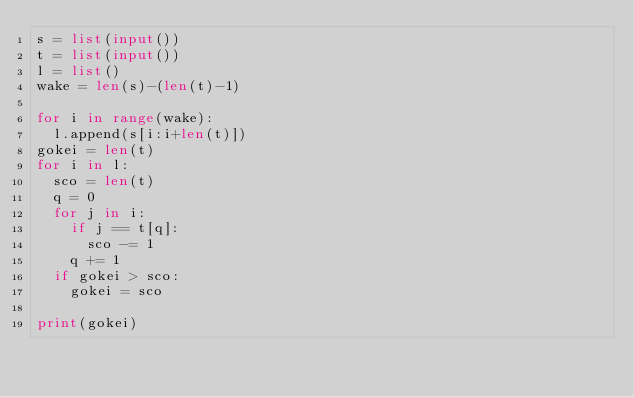Convert code to text. <code><loc_0><loc_0><loc_500><loc_500><_Python_>s = list(input())
t = list(input())
l = list()
wake = len(s)-(len(t)-1)

for i in range(wake):
  l.append(s[i:i+len(t)])
gokei = len(t)
for i in l:
  sco = len(t)
  q = 0
  for j in i:
    if j == t[q]:
      sco -= 1
    q += 1
  if gokei > sco:
    gokei = sco
    
print(gokei)</code> 